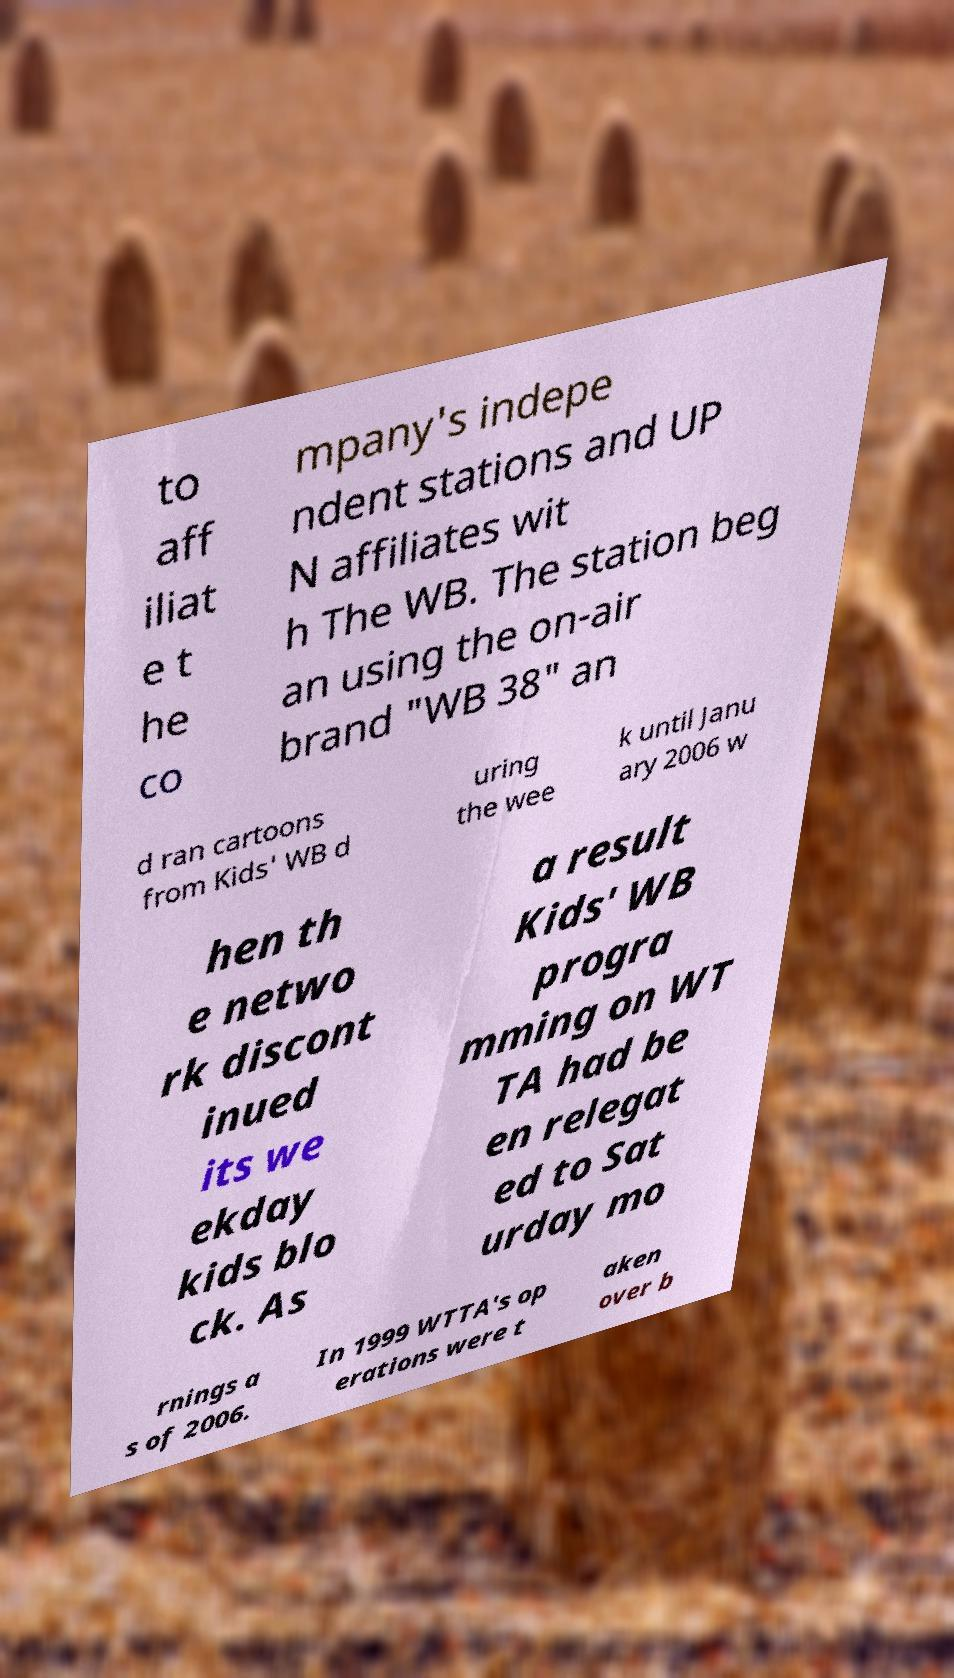Please identify and transcribe the text found in this image. to aff iliat e t he co mpany's indepe ndent stations and UP N affiliates wit h The WB. The station beg an using the on-air brand "WB 38" an d ran cartoons from Kids' WB d uring the wee k until Janu ary 2006 w hen th e netwo rk discont inued its we ekday kids blo ck. As a result Kids' WB progra mming on WT TA had be en relegat ed to Sat urday mo rnings a s of 2006. In 1999 WTTA's op erations were t aken over b 